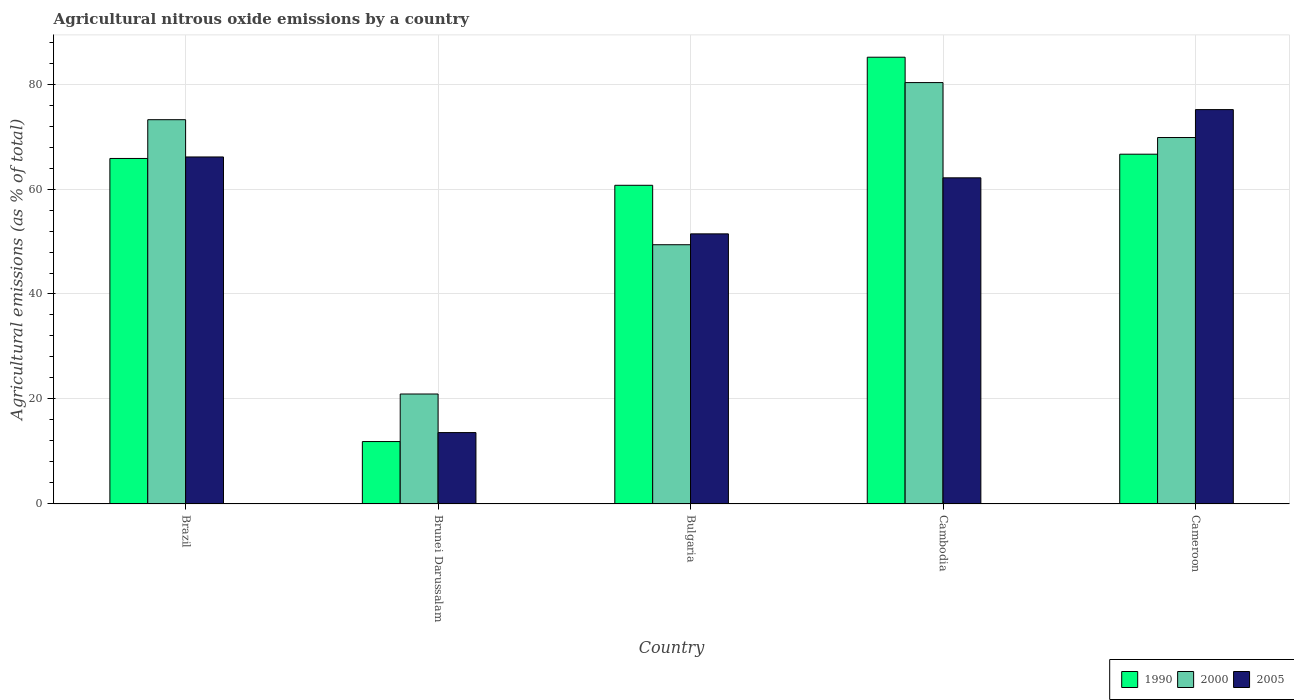How many different coloured bars are there?
Offer a terse response. 3. Are the number of bars on each tick of the X-axis equal?
Your response must be concise. Yes. How many bars are there on the 2nd tick from the right?
Your response must be concise. 3. What is the label of the 4th group of bars from the left?
Ensure brevity in your answer.  Cambodia. What is the amount of agricultural nitrous oxide emitted in 2000 in Brazil?
Your answer should be very brief. 73.21. Across all countries, what is the maximum amount of agricultural nitrous oxide emitted in 2000?
Your response must be concise. 80.27. Across all countries, what is the minimum amount of agricultural nitrous oxide emitted in 2000?
Provide a short and direct response. 20.95. In which country was the amount of agricultural nitrous oxide emitted in 1990 maximum?
Give a very brief answer. Cambodia. In which country was the amount of agricultural nitrous oxide emitted in 1990 minimum?
Keep it short and to the point. Brunei Darussalam. What is the total amount of agricultural nitrous oxide emitted in 1990 in the graph?
Keep it short and to the point. 290.16. What is the difference between the amount of agricultural nitrous oxide emitted in 1990 in Bulgaria and that in Cameroon?
Your answer should be compact. -5.93. What is the difference between the amount of agricultural nitrous oxide emitted in 2000 in Bulgaria and the amount of agricultural nitrous oxide emitted in 2005 in Cambodia?
Offer a terse response. -12.74. What is the average amount of agricultural nitrous oxide emitted in 2000 per country?
Provide a succinct answer. 58.72. What is the difference between the amount of agricultural nitrous oxide emitted of/in 1990 and amount of agricultural nitrous oxide emitted of/in 2005 in Brazil?
Offer a terse response. -0.29. What is the ratio of the amount of agricultural nitrous oxide emitted in 2000 in Brazil to that in Bulgaria?
Keep it short and to the point. 1.48. Is the amount of agricultural nitrous oxide emitted in 2000 in Brunei Darussalam less than that in Cambodia?
Give a very brief answer. Yes. What is the difference between the highest and the second highest amount of agricultural nitrous oxide emitted in 2000?
Ensure brevity in your answer.  7.07. What is the difference between the highest and the lowest amount of agricultural nitrous oxide emitted in 2000?
Ensure brevity in your answer.  59.33. In how many countries, is the amount of agricultural nitrous oxide emitted in 2000 greater than the average amount of agricultural nitrous oxide emitted in 2000 taken over all countries?
Provide a short and direct response. 3. Is the sum of the amount of agricultural nitrous oxide emitted in 1990 in Bulgaria and Cambodia greater than the maximum amount of agricultural nitrous oxide emitted in 2005 across all countries?
Offer a terse response. Yes. What does the 3rd bar from the left in Cambodia represents?
Provide a short and direct response. 2005. Is it the case that in every country, the sum of the amount of agricultural nitrous oxide emitted in 2000 and amount of agricultural nitrous oxide emitted in 2005 is greater than the amount of agricultural nitrous oxide emitted in 1990?
Provide a succinct answer. Yes. Are the values on the major ticks of Y-axis written in scientific E-notation?
Your response must be concise. No. Does the graph contain any zero values?
Your answer should be compact. No. Does the graph contain grids?
Provide a succinct answer. Yes. Where does the legend appear in the graph?
Give a very brief answer. Bottom right. How many legend labels are there?
Provide a succinct answer. 3. How are the legend labels stacked?
Give a very brief answer. Horizontal. What is the title of the graph?
Provide a succinct answer. Agricultural nitrous oxide emissions by a country. What is the label or title of the X-axis?
Your answer should be compact. Country. What is the label or title of the Y-axis?
Your answer should be compact. Agricultural emissions (as % of total). What is the Agricultural emissions (as % of total) of 1990 in Brazil?
Give a very brief answer. 65.82. What is the Agricultural emissions (as % of total) of 2000 in Brazil?
Your response must be concise. 73.21. What is the Agricultural emissions (as % of total) in 2005 in Brazil?
Your response must be concise. 66.11. What is the Agricultural emissions (as % of total) of 1990 in Brunei Darussalam?
Ensure brevity in your answer.  11.89. What is the Agricultural emissions (as % of total) in 2000 in Brunei Darussalam?
Keep it short and to the point. 20.95. What is the Agricultural emissions (as % of total) in 2005 in Brunei Darussalam?
Offer a terse response. 13.6. What is the Agricultural emissions (as % of total) of 1990 in Bulgaria?
Your answer should be compact. 60.71. What is the Agricultural emissions (as % of total) of 2000 in Bulgaria?
Your answer should be very brief. 49.39. What is the Agricultural emissions (as % of total) of 2005 in Bulgaria?
Ensure brevity in your answer.  51.46. What is the Agricultural emissions (as % of total) in 1990 in Cambodia?
Offer a terse response. 85.11. What is the Agricultural emissions (as % of total) of 2000 in Cambodia?
Provide a short and direct response. 80.27. What is the Agricultural emissions (as % of total) in 2005 in Cambodia?
Offer a terse response. 62.13. What is the Agricultural emissions (as % of total) in 1990 in Cameroon?
Keep it short and to the point. 66.63. What is the Agricultural emissions (as % of total) in 2000 in Cameroon?
Offer a terse response. 69.81. What is the Agricultural emissions (as % of total) in 2005 in Cameroon?
Your answer should be very brief. 75.13. Across all countries, what is the maximum Agricultural emissions (as % of total) in 1990?
Provide a short and direct response. 85.11. Across all countries, what is the maximum Agricultural emissions (as % of total) in 2000?
Provide a short and direct response. 80.27. Across all countries, what is the maximum Agricultural emissions (as % of total) of 2005?
Keep it short and to the point. 75.13. Across all countries, what is the minimum Agricultural emissions (as % of total) in 1990?
Give a very brief answer. 11.89. Across all countries, what is the minimum Agricultural emissions (as % of total) of 2000?
Ensure brevity in your answer.  20.95. Across all countries, what is the minimum Agricultural emissions (as % of total) in 2005?
Offer a very short reply. 13.6. What is the total Agricultural emissions (as % of total) of 1990 in the graph?
Make the answer very short. 290.16. What is the total Agricultural emissions (as % of total) in 2000 in the graph?
Your answer should be compact. 293.62. What is the total Agricultural emissions (as % of total) in 2005 in the graph?
Your answer should be compact. 268.42. What is the difference between the Agricultural emissions (as % of total) in 1990 in Brazil and that in Brunei Darussalam?
Make the answer very short. 53.93. What is the difference between the Agricultural emissions (as % of total) in 2000 in Brazil and that in Brunei Darussalam?
Give a very brief answer. 52.26. What is the difference between the Agricultural emissions (as % of total) in 2005 in Brazil and that in Brunei Darussalam?
Offer a terse response. 52.51. What is the difference between the Agricultural emissions (as % of total) in 1990 in Brazil and that in Bulgaria?
Give a very brief answer. 5.11. What is the difference between the Agricultural emissions (as % of total) in 2000 in Brazil and that in Bulgaria?
Your response must be concise. 23.82. What is the difference between the Agricultural emissions (as % of total) in 2005 in Brazil and that in Bulgaria?
Keep it short and to the point. 14.65. What is the difference between the Agricultural emissions (as % of total) of 1990 in Brazil and that in Cambodia?
Your response must be concise. -19.29. What is the difference between the Agricultural emissions (as % of total) of 2000 in Brazil and that in Cambodia?
Offer a very short reply. -7.07. What is the difference between the Agricultural emissions (as % of total) of 2005 in Brazil and that in Cambodia?
Offer a terse response. 3.97. What is the difference between the Agricultural emissions (as % of total) of 1990 in Brazil and that in Cameroon?
Your answer should be compact. -0.81. What is the difference between the Agricultural emissions (as % of total) of 2000 in Brazil and that in Cameroon?
Ensure brevity in your answer.  3.4. What is the difference between the Agricultural emissions (as % of total) of 2005 in Brazil and that in Cameroon?
Ensure brevity in your answer.  -9.02. What is the difference between the Agricultural emissions (as % of total) of 1990 in Brunei Darussalam and that in Bulgaria?
Offer a terse response. -48.82. What is the difference between the Agricultural emissions (as % of total) of 2000 in Brunei Darussalam and that in Bulgaria?
Your answer should be very brief. -28.44. What is the difference between the Agricultural emissions (as % of total) of 2005 in Brunei Darussalam and that in Bulgaria?
Make the answer very short. -37.86. What is the difference between the Agricultural emissions (as % of total) in 1990 in Brunei Darussalam and that in Cambodia?
Make the answer very short. -73.22. What is the difference between the Agricultural emissions (as % of total) of 2000 in Brunei Darussalam and that in Cambodia?
Keep it short and to the point. -59.33. What is the difference between the Agricultural emissions (as % of total) of 2005 in Brunei Darussalam and that in Cambodia?
Offer a terse response. -48.53. What is the difference between the Agricultural emissions (as % of total) in 1990 in Brunei Darussalam and that in Cameroon?
Your answer should be very brief. -54.74. What is the difference between the Agricultural emissions (as % of total) of 2000 in Brunei Darussalam and that in Cameroon?
Offer a very short reply. -48.86. What is the difference between the Agricultural emissions (as % of total) in 2005 in Brunei Darussalam and that in Cameroon?
Your answer should be very brief. -61.53. What is the difference between the Agricultural emissions (as % of total) of 1990 in Bulgaria and that in Cambodia?
Provide a succinct answer. -24.4. What is the difference between the Agricultural emissions (as % of total) in 2000 in Bulgaria and that in Cambodia?
Ensure brevity in your answer.  -30.89. What is the difference between the Agricultural emissions (as % of total) of 2005 in Bulgaria and that in Cambodia?
Your answer should be very brief. -10.67. What is the difference between the Agricultural emissions (as % of total) of 1990 in Bulgaria and that in Cameroon?
Keep it short and to the point. -5.93. What is the difference between the Agricultural emissions (as % of total) in 2000 in Bulgaria and that in Cameroon?
Offer a terse response. -20.42. What is the difference between the Agricultural emissions (as % of total) of 2005 in Bulgaria and that in Cameroon?
Provide a short and direct response. -23.67. What is the difference between the Agricultural emissions (as % of total) of 1990 in Cambodia and that in Cameroon?
Your answer should be compact. 18.47. What is the difference between the Agricultural emissions (as % of total) in 2000 in Cambodia and that in Cameroon?
Make the answer very short. 10.47. What is the difference between the Agricultural emissions (as % of total) in 2005 in Cambodia and that in Cameroon?
Ensure brevity in your answer.  -13. What is the difference between the Agricultural emissions (as % of total) in 1990 in Brazil and the Agricultural emissions (as % of total) in 2000 in Brunei Darussalam?
Give a very brief answer. 44.87. What is the difference between the Agricultural emissions (as % of total) of 1990 in Brazil and the Agricultural emissions (as % of total) of 2005 in Brunei Darussalam?
Your answer should be very brief. 52.22. What is the difference between the Agricultural emissions (as % of total) of 2000 in Brazil and the Agricultural emissions (as % of total) of 2005 in Brunei Darussalam?
Keep it short and to the point. 59.61. What is the difference between the Agricultural emissions (as % of total) of 1990 in Brazil and the Agricultural emissions (as % of total) of 2000 in Bulgaria?
Offer a terse response. 16.43. What is the difference between the Agricultural emissions (as % of total) in 1990 in Brazil and the Agricultural emissions (as % of total) in 2005 in Bulgaria?
Offer a terse response. 14.36. What is the difference between the Agricultural emissions (as % of total) of 2000 in Brazil and the Agricultural emissions (as % of total) of 2005 in Bulgaria?
Provide a succinct answer. 21.75. What is the difference between the Agricultural emissions (as % of total) in 1990 in Brazil and the Agricultural emissions (as % of total) in 2000 in Cambodia?
Keep it short and to the point. -14.45. What is the difference between the Agricultural emissions (as % of total) of 1990 in Brazil and the Agricultural emissions (as % of total) of 2005 in Cambodia?
Your response must be concise. 3.69. What is the difference between the Agricultural emissions (as % of total) in 2000 in Brazil and the Agricultural emissions (as % of total) in 2005 in Cambodia?
Offer a terse response. 11.07. What is the difference between the Agricultural emissions (as % of total) in 1990 in Brazil and the Agricultural emissions (as % of total) in 2000 in Cameroon?
Ensure brevity in your answer.  -3.99. What is the difference between the Agricultural emissions (as % of total) of 1990 in Brazil and the Agricultural emissions (as % of total) of 2005 in Cameroon?
Keep it short and to the point. -9.31. What is the difference between the Agricultural emissions (as % of total) in 2000 in Brazil and the Agricultural emissions (as % of total) in 2005 in Cameroon?
Give a very brief answer. -1.92. What is the difference between the Agricultural emissions (as % of total) of 1990 in Brunei Darussalam and the Agricultural emissions (as % of total) of 2000 in Bulgaria?
Your answer should be compact. -37.5. What is the difference between the Agricultural emissions (as % of total) in 1990 in Brunei Darussalam and the Agricultural emissions (as % of total) in 2005 in Bulgaria?
Provide a short and direct response. -39.57. What is the difference between the Agricultural emissions (as % of total) of 2000 in Brunei Darussalam and the Agricultural emissions (as % of total) of 2005 in Bulgaria?
Offer a very short reply. -30.51. What is the difference between the Agricultural emissions (as % of total) of 1990 in Brunei Darussalam and the Agricultural emissions (as % of total) of 2000 in Cambodia?
Ensure brevity in your answer.  -68.39. What is the difference between the Agricultural emissions (as % of total) in 1990 in Brunei Darussalam and the Agricultural emissions (as % of total) in 2005 in Cambodia?
Make the answer very short. -50.24. What is the difference between the Agricultural emissions (as % of total) in 2000 in Brunei Darussalam and the Agricultural emissions (as % of total) in 2005 in Cambodia?
Provide a short and direct response. -41.18. What is the difference between the Agricultural emissions (as % of total) of 1990 in Brunei Darussalam and the Agricultural emissions (as % of total) of 2000 in Cameroon?
Keep it short and to the point. -57.92. What is the difference between the Agricultural emissions (as % of total) of 1990 in Brunei Darussalam and the Agricultural emissions (as % of total) of 2005 in Cameroon?
Provide a short and direct response. -63.24. What is the difference between the Agricultural emissions (as % of total) of 2000 in Brunei Darussalam and the Agricultural emissions (as % of total) of 2005 in Cameroon?
Ensure brevity in your answer.  -54.18. What is the difference between the Agricultural emissions (as % of total) in 1990 in Bulgaria and the Agricultural emissions (as % of total) in 2000 in Cambodia?
Offer a very short reply. -19.57. What is the difference between the Agricultural emissions (as % of total) of 1990 in Bulgaria and the Agricultural emissions (as % of total) of 2005 in Cambodia?
Ensure brevity in your answer.  -1.42. What is the difference between the Agricultural emissions (as % of total) of 2000 in Bulgaria and the Agricultural emissions (as % of total) of 2005 in Cambodia?
Make the answer very short. -12.74. What is the difference between the Agricultural emissions (as % of total) of 1990 in Bulgaria and the Agricultural emissions (as % of total) of 2000 in Cameroon?
Your answer should be very brief. -9.1. What is the difference between the Agricultural emissions (as % of total) in 1990 in Bulgaria and the Agricultural emissions (as % of total) in 2005 in Cameroon?
Offer a terse response. -14.42. What is the difference between the Agricultural emissions (as % of total) of 2000 in Bulgaria and the Agricultural emissions (as % of total) of 2005 in Cameroon?
Your response must be concise. -25.74. What is the difference between the Agricultural emissions (as % of total) in 1990 in Cambodia and the Agricultural emissions (as % of total) in 2000 in Cameroon?
Give a very brief answer. 15.3. What is the difference between the Agricultural emissions (as % of total) of 1990 in Cambodia and the Agricultural emissions (as % of total) of 2005 in Cameroon?
Your response must be concise. 9.98. What is the difference between the Agricultural emissions (as % of total) of 2000 in Cambodia and the Agricultural emissions (as % of total) of 2005 in Cameroon?
Ensure brevity in your answer.  5.15. What is the average Agricultural emissions (as % of total) in 1990 per country?
Offer a terse response. 58.03. What is the average Agricultural emissions (as % of total) in 2000 per country?
Your answer should be very brief. 58.72. What is the average Agricultural emissions (as % of total) of 2005 per country?
Your answer should be very brief. 53.68. What is the difference between the Agricultural emissions (as % of total) in 1990 and Agricultural emissions (as % of total) in 2000 in Brazil?
Offer a terse response. -7.39. What is the difference between the Agricultural emissions (as % of total) of 1990 and Agricultural emissions (as % of total) of 2005 in Brazil?
Make the answer very short. -0.29. What is the difference between the Agricultural emissions (as % of total) of 2000 and Agricultural emissions (as % of total) of 2005 in Brazil?
Keep it short and to the point. 7.1. What is the difference between the Agricultural emissions (as % of total) in 1990 and Agricultural emissions (as % of total) in 2000 in Brunei Darussalam?
Give a very brief answer. -9.06. What is the difference between the Agricultural emissions (as % of total) of 1990 and Agricultural emissions (as % of total) of 2005 in Brunei Darussalam?
Offer a very short reply. -1.71. What is the difference between the Agricultural emissions (as % of total) of 2000 and Agricultural emissions (as % of total) of 2005 in Brunei Darussalam?
Offer a terse response. 7.35. What is the difference between the Agricultural emissions (as % of total) of 1990 and Agricultural emissions (as % of total) of 2000 in Bulgaria?
Offer a terse response. 11.32. What is the difference between the Agricultural emissions (as % of total) in 1990 and Agricultural emissions (as % of total) in 2005 in Bulgaria?
Give a very brief answer. 9.25. What is the difference between the Agricultural emissions (as % of total) in 2000 and Agricultural emissions (as % of total) in 2005 in Bulgaria?
Your answer should be compact. -2.07. What is the difference between the Agricultural emissions (as % of total) of 1990 and Agricultural emissions (as % of total) of 2000 in Cambodia?
Offer a very short reply. 4.83. What is the difference between the Agricultural emissions (as % of total) in 1990 and Agricultural emissions (as % of total) in 2005 in Cambodia?
Offer a terse response. 22.98. What is the difference between the Agricultural emissions (as % of total) in 2000 and Agricultural emissions (as % of total) in 2005 in Cambodia?
Offer a terse response. 18.14. What is the difference between the Agricultural emissions (as % of total) in 1990 and Agricultural emissions (as % of total) in 2000 in Cameroon?
Ensure brevity in your answer.  -3.18. What is the difference between the Agricultural emissions (as % of total) in 1990 and Agricultural emissions (as % of total) in 2005 in Cameroon?
Provide a succinct answer. -8.49. What is the difference between the Agricultural emissions (as % of total) in 2000 and Agricultural emissions (as % of total) in 2005 in Cameroon?
Your response must be concise. -5.32. What is the ratio of the Agricultural emissions (as % of total) of 1990 in Brazil to that in Brunei Darussalam?
Make the answer very short. 5.54. What is the ratio of the Agricultural emissions (as % of total) in 2000 in Brazil to that in Brunei Darussalam?
Offer a very short reply. 3.49. What is the ratio of the Agricultural emissions (as % of total) of 2005 in Brazil to that in Brunei Darussalam?
Offer a very short reply. 4.86. What is the ratio of the Agricultural emissions (as % of total) of 1990 in Brazil to that in Bulgaria?
Your response must be concise. 1.08. What is the ratio of the Agricultural emissions (as % of total) in 2000 in Brazil to that in Bulgaria?
Provide a succinct answer. 1.48. What is the ratio of the Agricultural emissions (as % of total) in 2005 in Brazil to that in Bulgaria?
Your answer should be very brief. 1.28. What is the ratio of the Agricultural emissions (as % of total) of 1990 in Brazil to that in Cambodia?
Ensure brevity in your answer.  0.77. What is the ratio of the Agricultural emissions (as % of total) of 2000 in Brazil to that in Cambodia?
Keep it short and to the point. 0.91. What is the ratio of the Agricultural emissions (as % of total) in 2005 in Brazil to that in Cambodia?
Provide a succinct answer. 1.06. What is the ratio of the Agricultural emissions (as % of total) in 1990 in Brazil to that in Cameroon?
Ensure brevity in your answer.  0.99. What is the ratio of the Agricultural emissions (as % of total) in 2000 in Brazil to that in Cameroon?
Your answer should be compact. 1.05. What is the ratio of the Agricultural emissions (as % of total) of 2005 in Brazil to that in Cameroon?
Make the answer very short. 0.88. What is the ratio of the Agricultural emissions (as % of total) in 1990 in Brunei Darussalam to that in Bulgaria?
Provide a short and direct response. 0.2. What is the ratio of the Agricultural emissions (as % of total) in 2000 in Brunei Darussalam to that in Bulgaria?
Your response must be concise. 0.42. What is the ratio of the Agricultural emissions (as % of total) of 2005 in Brunei Darussalam to that in Bulgaria?
Ensure brevity in your answer.  0.26. What is the ratio of the Agricultural emissions (as % of total) in 1990 in Brunei Darussalam to that in Cambodia?
Your answer should be very brief. 0.14. What is the ratio of the Agricultural emissions (as % of total) of 2000 in Brunei Darussalam to that in Cambodia?
Offer a very short reply. 0.26. What is the ratio of the Agricultural emissions (as % of total) in 2005 in Brunei Darussalam to that in Cambodia?
Your answer should be very brief. 0.22. What is the ratio of the Agricultural emissions (as % of total) in 1990 in Brunei Darussalam to that in Cameroon?
Offer a very short reply. 0.18. What is the ratio of the Agricultural emissions (as % of total) in 2000 in Brunei Darussalam to that in Cameroon?
Ensure brevity in your answer.  0.3. What is the ratio of the Agricultural emissions (as % of total) of 2005 in Brunei Darussalam to that in Cameroon?
Offer a very short reply. 0.18. What is the ratio of the Agricultural emissions (as % of total) of 1990 in Bulgaria to that in Cambodia?
Give a very brief answer. 0.71. What is the ratio of the Agricultural emissions (as % of total) in 2000 in Bulgaria to that in Cambodia?
Keep it short and to the point. 0.62. What is the ratio of the Agricultural emissions (as % of total) in 2005 in Bulgaria to that in Cambodia?
Your answer should be compact. 0.83. What is the ratio of the Agricultural emissions (as % of total) in 1990 in Bulgaria to that in Cameroon?
Your answer should be very brief. 0.91. What is the ratio of the Agricultural emissions (as % of total) of 2000 in Bulgaria to that in Cameroon?
Provide a succinct answer. 0.71. What is the ratio of the Agricultural emissions (as % of total) in 2005 in Bulgaria to that in Cameroon?
Offer a very short reply. 0.68. What is the ratio of the Agricultural emissions (as % of total) of 1990 in Cambodia to that in Cameroon?
Offer a very short reply. 1.28. What is the ratio of the Agricultural emissions (as % of total) in 2000 in Cambodia to that in Cameroon?
Offer a terse response. 1.15. What is the ratio of the Agricultural emissions (as % of total) of 2005 in Cambodia to that in Cameroon?
Keep it short and to the point. 0.83. What is the difference between the highest and the second highest Agricultural emissions (as % of total) of 1990?
Offer a very short reply. 18.47. What is the difference between the highest and the second highest Agricultural emissions (as % of total) of 2000?
Make the answer very short. 7.07. What is the difference between the highest and the second highest Agricultural emissions (as % of total) in 2005?
Ensure brevity in your answer.  9.02. What is the difference between the highest and the lowest Agricultural emissions (as % of total) in 1990?
Your answer should be compact. 73.22. What is the difference between the highest and the lowest Agricultural emissions (as % of total) of 2000?
Ensure brevity in your answer.  59.33. What is the difference between the highest and the lowest Agricultural emissions (as % of total) of 2005?
Offer a very short reply. 61.53. 